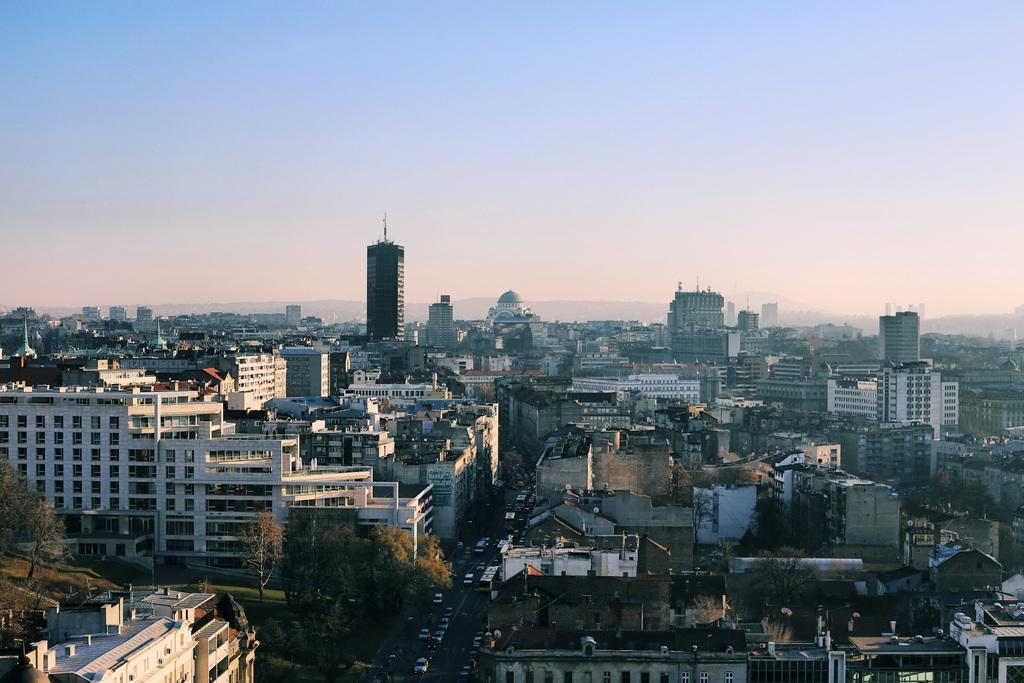What type of structures can be seen in the image? There are buildings in the image. What feature of the buildings is visible in the image? There are windows visible in the image. What type of natural elements can be seen in the image? There are trees in the image. What part of the natural environment is visible in the image? The sky is visible in the image. What type of man-made objects can be seen on the road in the image? There are vehicles on the road in the image. Can you describe the discussion taking place between the geese in the image? There are no geese present in the image, so there is no discussion to describe. 